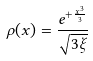<formula> <loc_0><loc_0><loc_500><loc_500>\rho ( x ) = \frac { e ^ { + \frac { x ^ { 3 } } { 3 } } } { \sqrt { 3 \xi } }</formula> 